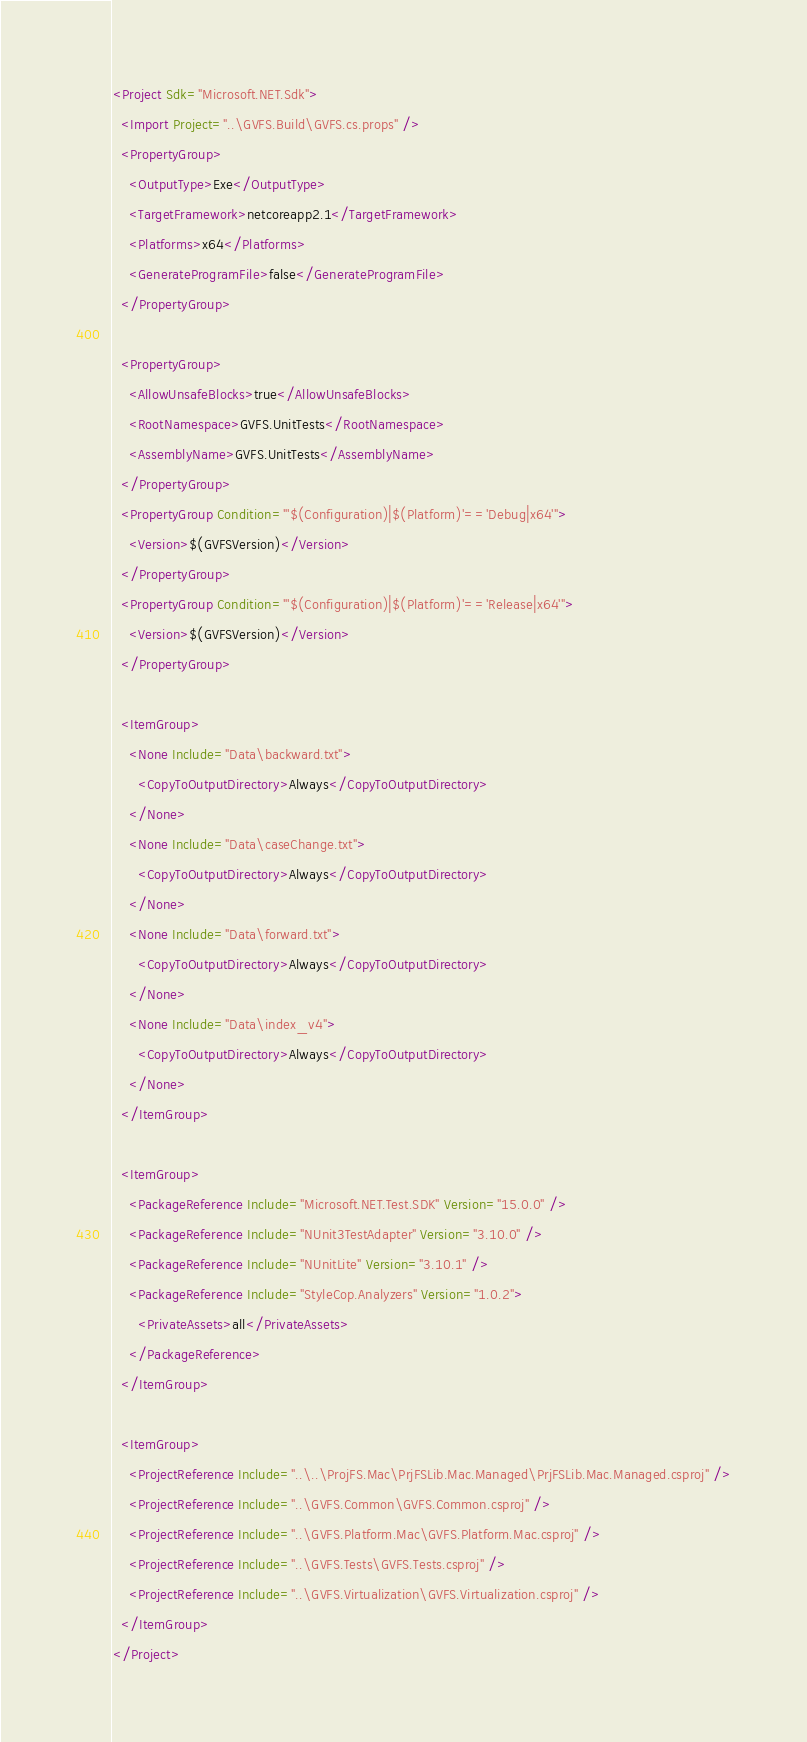Convert code to text. <code><loc_0><loc_0><loc_500><loc_500><_XML_><Project Sdk="Microsoft.NET.Sdk">
  <Import Project="..\GVFS.Build\GVFS.cs.props" />
  <PropertyGroup>
    <OutputType>Exe</OutputType>
    <TargetFramework>netcoreapp2.1</TargetFramework>
    <Platforms>x64</Platforms>
    <GenerateProgramFile>false</GenerateProgramFile>
  </PropertyGroup>
  
  <PropertyGroup>
    <AllowUnsafeBlocks>true</AllowUnsafeBlocks>
    <RootNamespace>GVFS.UnitTests</RootNamespace>
    <AssemblyName>GVFS.UnitTests</AssemblyName>
  </PropertyGroup>
  <PropertyGroup Condition="'$(Configuration)|$(Platform)'=='Debug|x64'">
    <Version>$(GVFSVersion)</Version>
  </PropertyGroup>
  <PropertyGroup Condition="'$(Configuration)|$(Platform)'=='Release|x64'">
    <Version>$(GVFSVersion)</Version>
  </PropertyGroup>
  
  <ItemGroup>
    <None Include="Data\backward.txt">
      <CopyToOutputDirectory>Always</CopyToOutputDirectory>
    </None>
    <None Include="Data\caseChange.txt">
      <CopyToOutputDirectory>Always</CopyToOutputDirectory>
    </None>
    <None Include="Data\forward.txt">
      <CopyToOutputDirectory>Always</CopyToOutputDirectory>
    </None>
    <None Include="Data\index_v4">
      <CopyToOutputDirectory>Always</CopyToOutputDirectory>
    </None>
  </ItemGroup>
  
  <ItemGroup>
    <PackageReference Include="Microsoft.NET.Test.SDK" Version="15.0.0" />
    <PackageReference Include="NUnit3TestAdapter" Version="3.10.0" />
    <PackageReference Include="NUnitLite" Version="3.10.1" />
    <PackageReference Include="StyleCop.Analyzers" Version="1.0.2">
      <PrivateAssets>all</PrivateAssets>
    </PackageReference>
  </ItemGroup>
  
  <ItemGroup>
    <ProjectReference Include="..\..\ProjFS.Mac\PrjFSLib.Mac.Managed\PrjFSLib.Mac.Managed.csproj" />
    <ProjectReference Include="..\GVFS.Common\GVFS.Common.csproj" />
    <ProjectReference Include="..\GVFS.Platform.Mac\GVFS.Platform.Mac.csproj" />
    <ProjectReference Include="..\GVFS.Tests\GVFS.Tests.csproj" />
    <ProjectReference Include="..\GVFS.Virtualization\GVFS.Virtualization.csproj" />
  </ItemGroup>
</Project>
</code> 